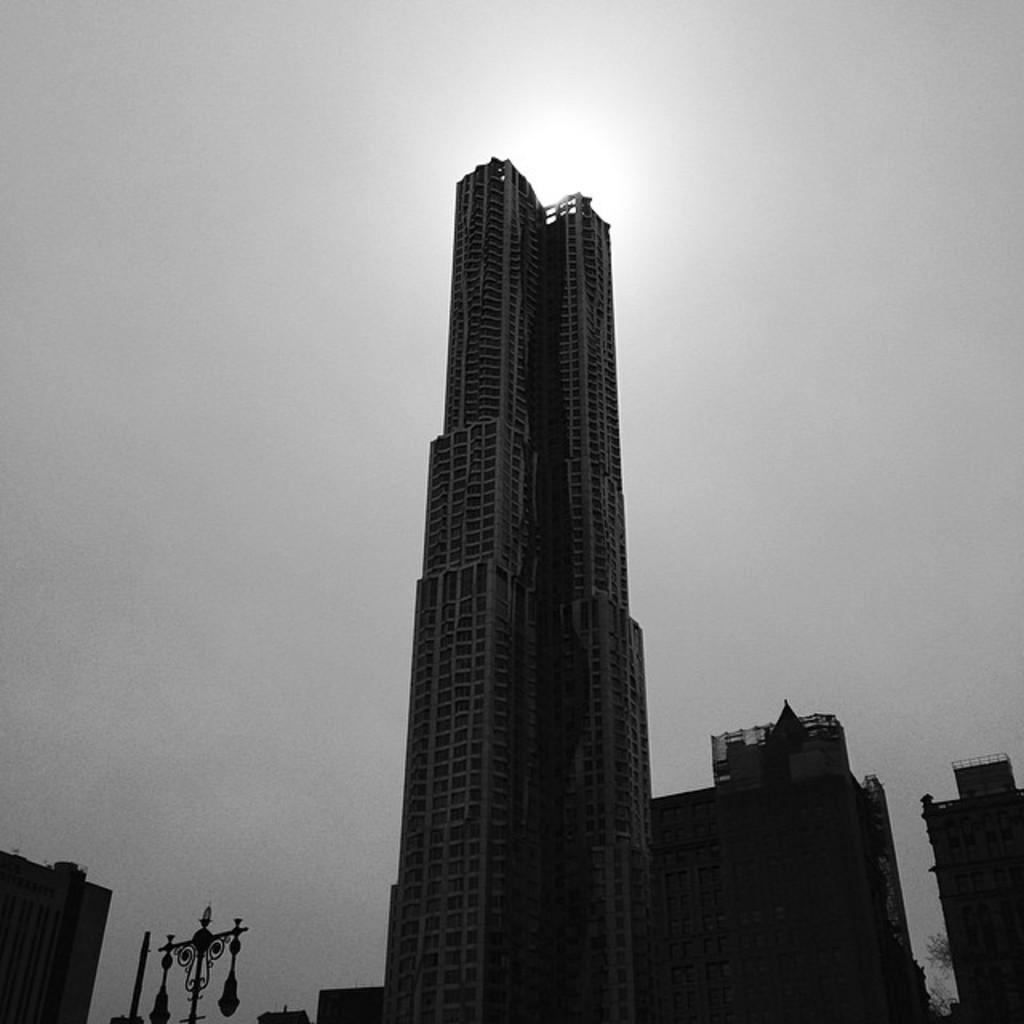What is the color scheme of the image? The image is black and white. What type of structures can be seen in the image? There are buildings in the image. What else is present in the image besides the buildings? There are poles in the image. What is visible at the top of the image? The sky is visible at the top of the image. What type of butter is being used to grease the corn in the image? There is no butter or corn present in the image; it features black and white buildings and poles. On which side of the image can the corn be found? There is no corn present in the image, so it cannot be found on any side. 